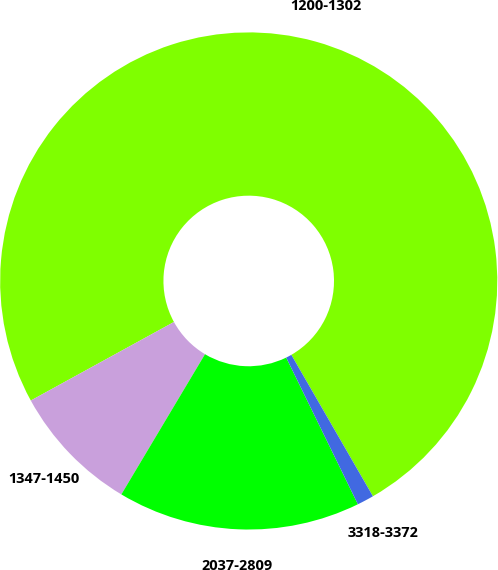<chart> <loc_0><loc_0><loc_500><loc_500><pie_chart><fcel>1200-1302<fcel>1347-1450<fcel>2037-2809<fcel>3318-3372<nl><fcel>74.66%<fcel>8.45%<fcel>15.8%<fcel>1.09%<nl></chart> 